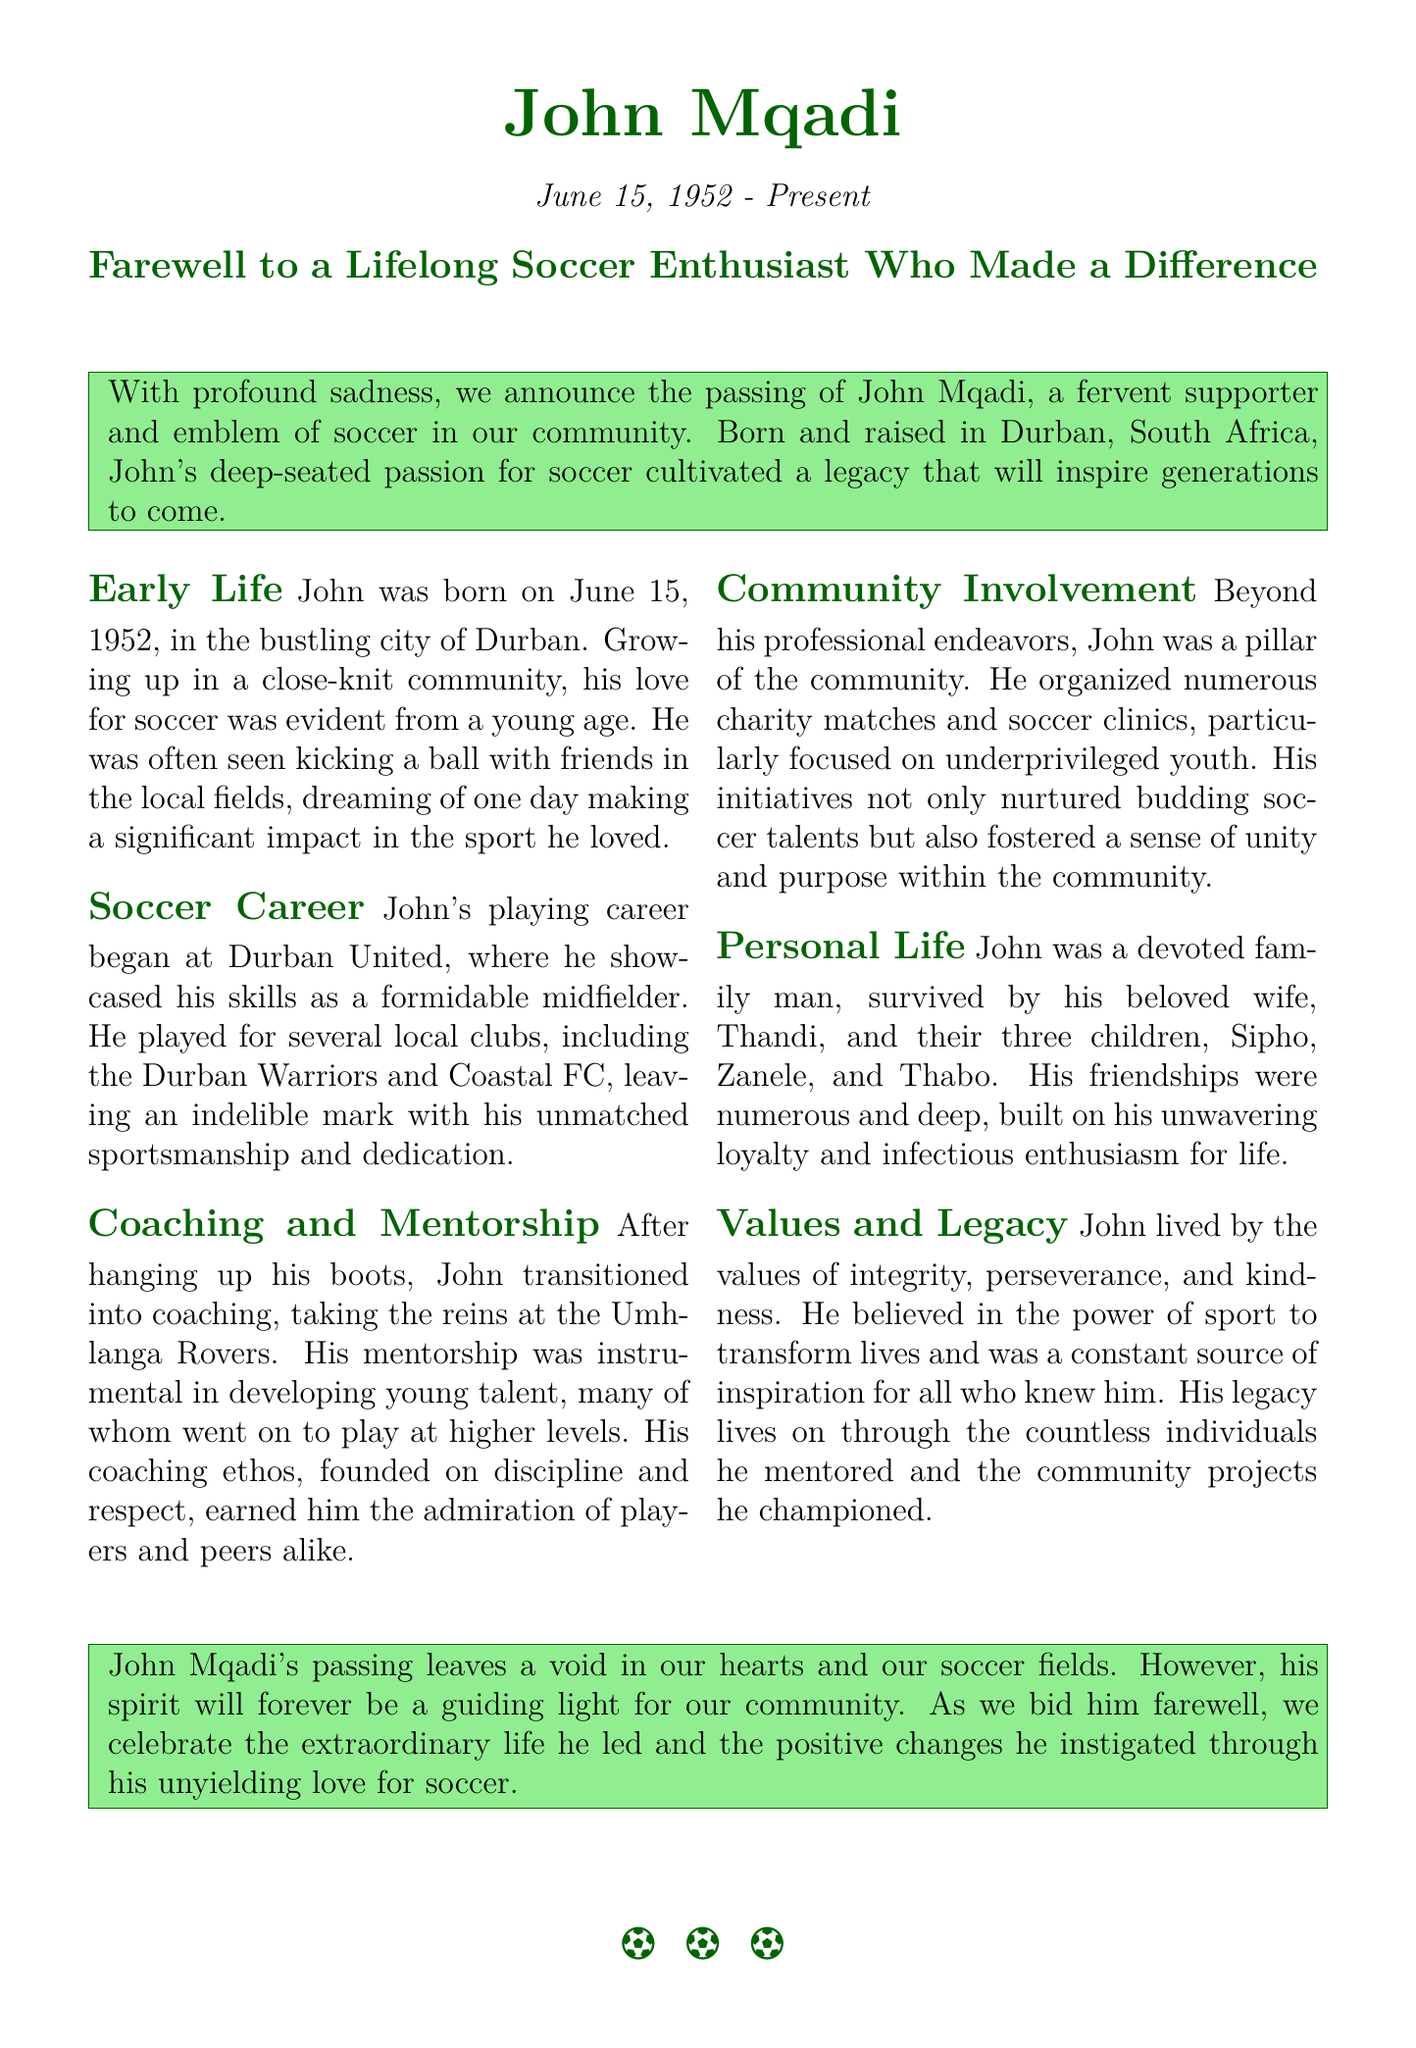What is the full name of the individual being honored? The document mentions "John Mqadi" as the individual being honored.
Answer: John Mqadi What was John's date of birth? The document states that John was born on June 15, 1952.
Answer: June 15, 1952 Which community club did John coach? The document specifies that John took the reins at the Umhlanga Rovers as a coach.
Answer: Umhlanga Rovers How many children did John have? The document indicates that John was survived by three children.
Answer: Three What was John's position in soccer? The document mentions that John showcased his skills as a formidable midfielder.
Answer: Midfielder What values did John live by? The document lists integrity, perseverance, and kindness as John's values.
Answer: Integrity, perseverance, and kindness In which city was John born? According to the document, John was born in Durban.
Answer: Durban What initiatives did John champion for the community? The document outlines that John organized charity matches and soccer clinics, particularly for underprivileged youth.
Answer: Charity matches and soccer clinics What was emphasized in John's coaching ethos? The document states that John's coaching ethos was founded on discipline and respect.
Answer: Discipline and respect 